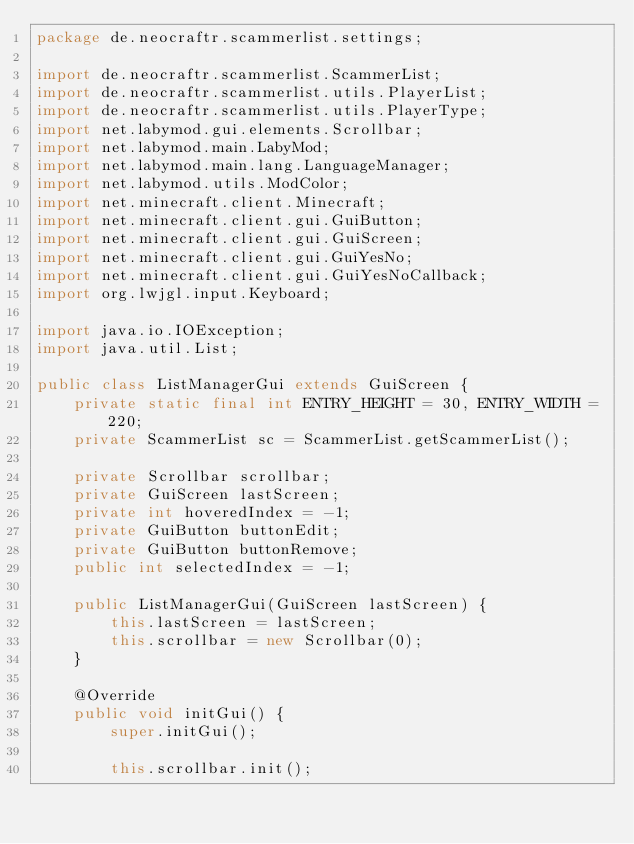Convert code to text. <code><loc_0><loc_0><loc_500><loc_500><_Java_>package de.neocraftr.scammerlist.settings;

import de.neocraftr.scammerlist.ScammerList;
import de.neocraftr.scammerlist.utils.PlayerList;
import de.neocraftr.scammerlist.utils.PlayerType;
import net.labymod.gui.elements.Scrollbar;
import net.labymod.main.LabyMod;
import net.labymod.main.lang.LanguageManager;
import net.labymod.utils.ModColor;
import net.minecraft.client.Minecraft;
import net.minecraft.client.gui.GuiButton;
import net.minecraft.client.gui.GuiScreen;
import net.minecraft.client.gui.GuiYesNo;
import net.minecraft.client.gui.GuiYesNoCallback;
import org.lwjgl.input.Keyboard;

import java.io.IOException;
import java.util.List;

public class ListManagerGui extends GuiScreen {
    private static final int ENTRY_HEIGHT = 30, ENTRY_WIDTH = 220;
    private ScammerList sc = ScammerList.getScammerList();

    private Scrollbar scrollbar;
    private GuiScreen lastScreen;
    private int hoveredIndex = -1;
    private GuiButton buttonEdit;
    private GuiButton buttonRemove;
    public int selectedIndex = -1;

    public ListManagerGui(GuiScreen lastScreen) {
        this.lastScreen = lastScreen;
        this.scrollbar = new Scrollbar(0);
    }

    @Override
    public void initGui() {
        super.initGui();

        this.scrollbar.init();</code> 